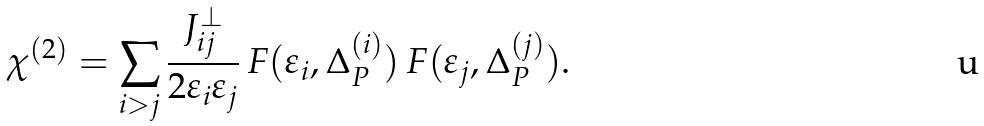Convert formula to latex. <formula><loc_0><loc_0><loc_500><loc_500>\chi ^ { ( 2 ) } = \sum _ { i > j } \frac { J _ { i j } ^ { \perp } } { 2 \varepsilon _ { i } \varepsilon _ { j } } \, F ( \varepsilon _ { i } , \Delta _ { P } ^ { ( i ) } ) \, F ( \varepsilon _ { j } , \Delta _ { P } ^ { ( j ) } ) .</formula> 